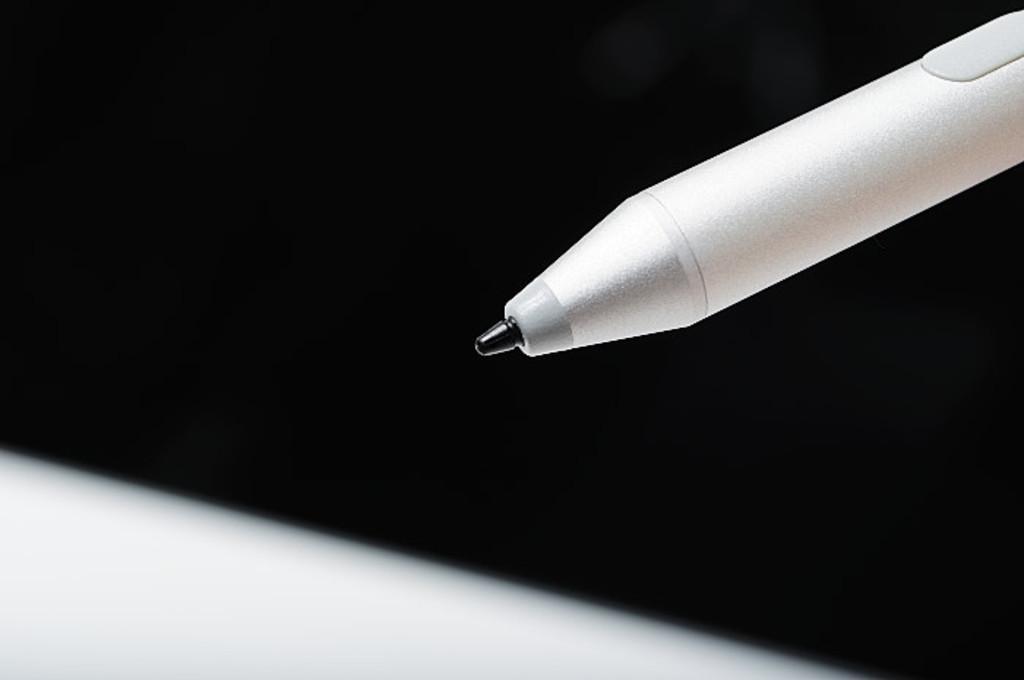Could you give a brief overview of what you see in this image? In this image the background is dark. On the right side of the image there is a pen which is white in color. 